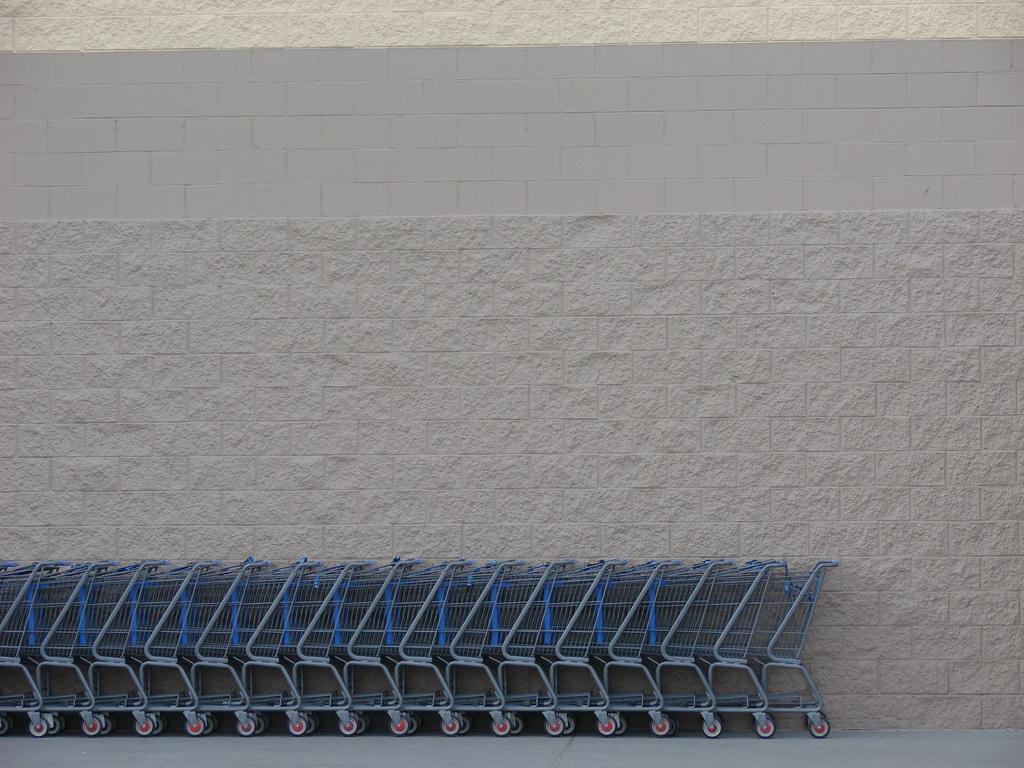In one or two sentences, can you explain what this image depicts? In this image I can see few shopping mall trolleys and the wall. 